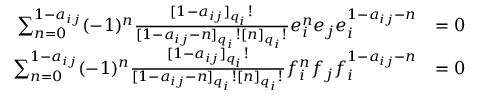<formula> <loc_0><loc_0><loc_500><loc_500>{ \begin{array} { r l } { \sum _ { n = 0 } ^ { 1 - a _ { i j } } ( - 1 ) ^ { n } { \frac { [ 1 - a _ { i j } ] _ { q _ { i } } ! } { [ 1 - a _ { i j } - n ] _ { q _ { i } } ! [ n ] _ { q _ { i } } ! } } e _ { i } ^ { n } e _ { j } e _ { i } ^ { 1 - a _ { i j } - n } } & { = 0 } \\ { \sum _ { n = 0 } ^ { 1 - a _ { i j } } ( - 1 ) ^ { n } { \frac { [ 1 - a _ { i j } ] _ { q _ { i } } ! } { [ 1 - a _ { i j } - n ] _ { q _ { i } } ! [ n ] _ { q _ { i } } ! } } f _ { i } ^ { n } f _ { j } f _ { i } ^ { 1 - a _ { i j } - n } } & { = 0 } \end{array} }</formula> 